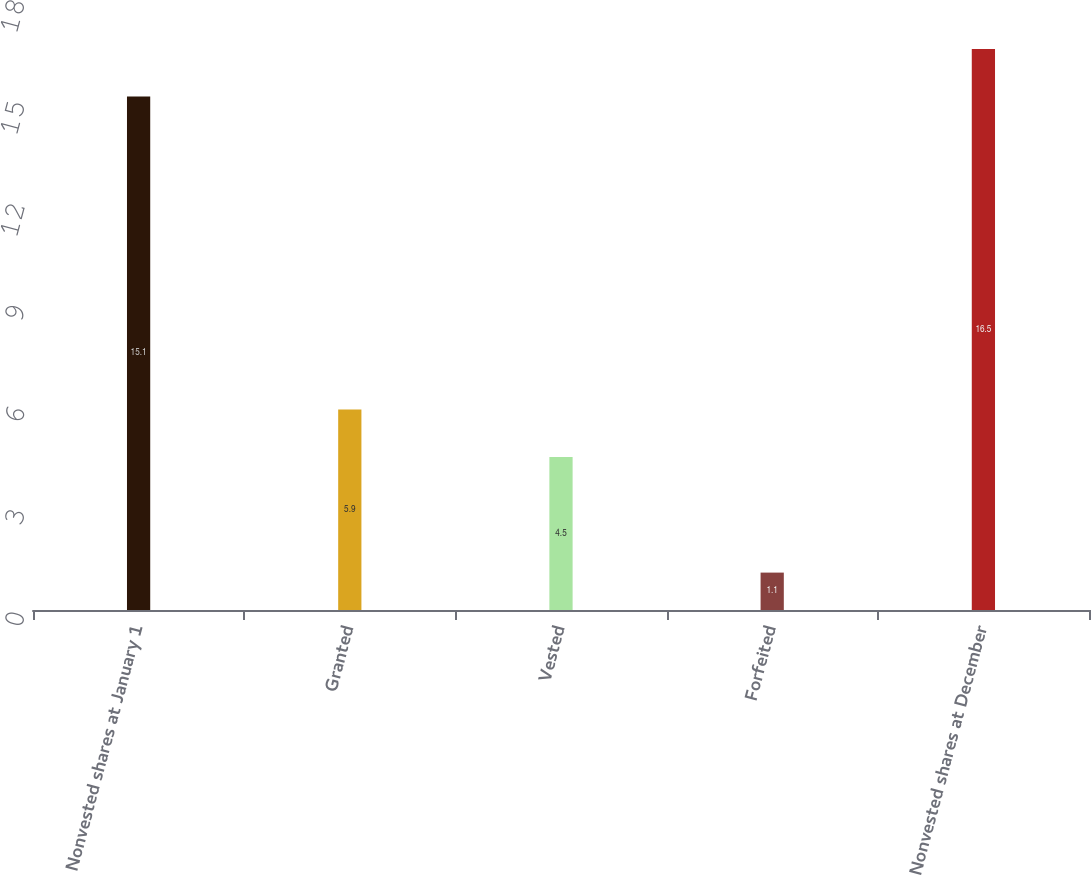<chart> <loc_0><loc_0><loc_500><loc_500><bar_chart><fcel>Nonvested shares at January 1<fcel>Granted<fcel>Vested<fcel>Forfeited<fcel>Nonvested shares at December<nl><fcel>15.1<fcel>5.9<fcel>4.5<fcel>1.1<fcel>16.5<nl></chart> 